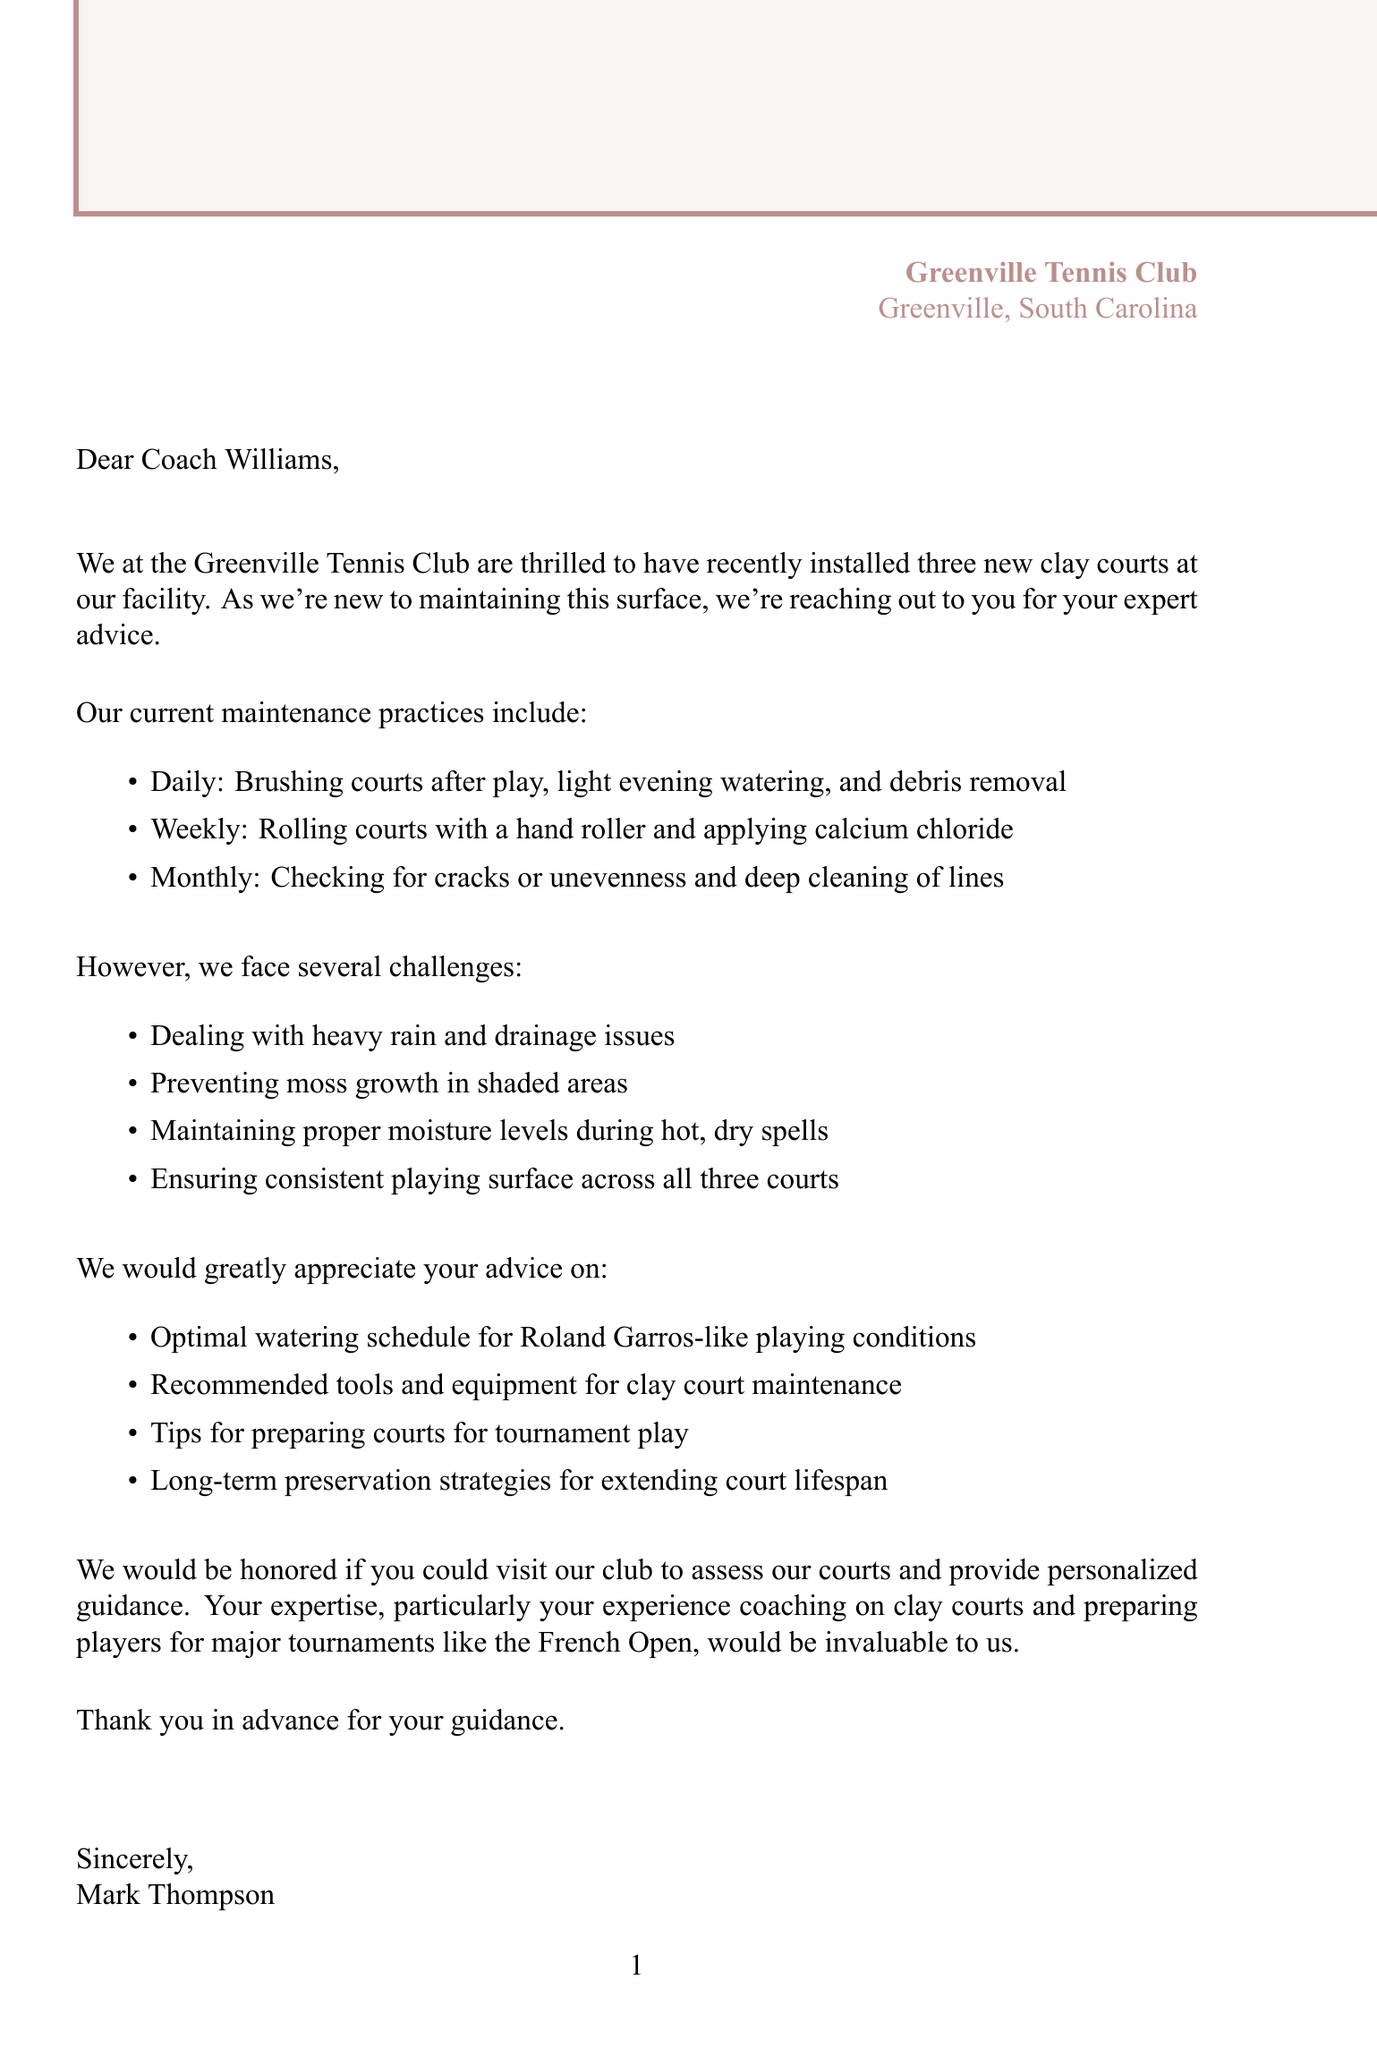What is the name of the club? The name of the club is mentioned in the closing statement of the letter.
Answer: Greenville Tennis Club How many new clay courts were installed? The number of new clay courts is stated in the introduction of the letter.
Answer: three Who is the president of the Greenville Tennis Club? The president's name is provided at the end of the letter.
Answer: Mark Thompson What is one of the specific challenges the club faces? The challenges are listed in the main body of the letter, and one is to prevent moss growth.
Answer: Preventing moss growth in shaded areas What type of surface are the new courts made of? The type of surface is stated early in the letter.
Answer: clay What is one of the advice requests from the club? The club's request for advice is mentioned in the main body, focusing on moisture levels.
Answer: Optimal watering schedule for Roland Garros-like playing conditions How long has Coach Williams been coaching? Coach Williams's experience is detailed in the letter.
Answer: 40+ years What does the club have in addition to the clay courts? The facilities are listed, and one is mentioned alongside the clay courts.
Answer: 4 hard courts 